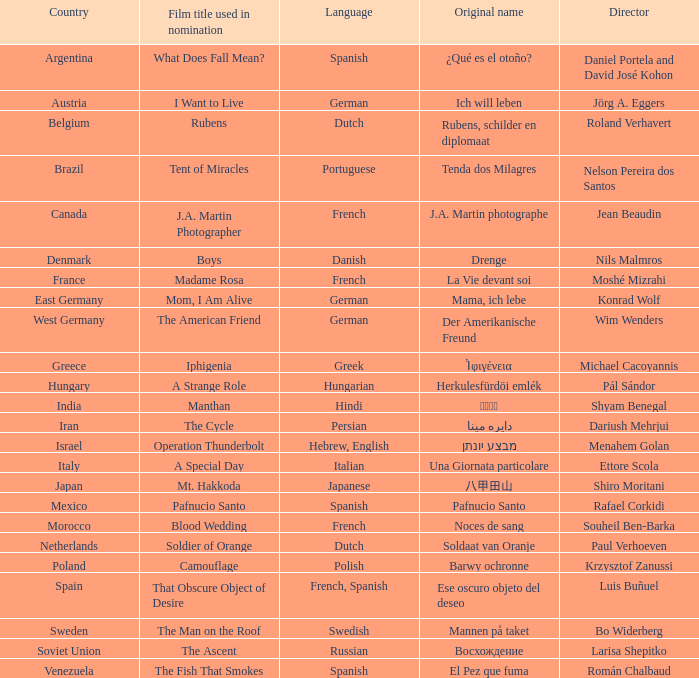What is the name of the german movie initially titled mama, ich lebe? Mom, I Am Alive. 